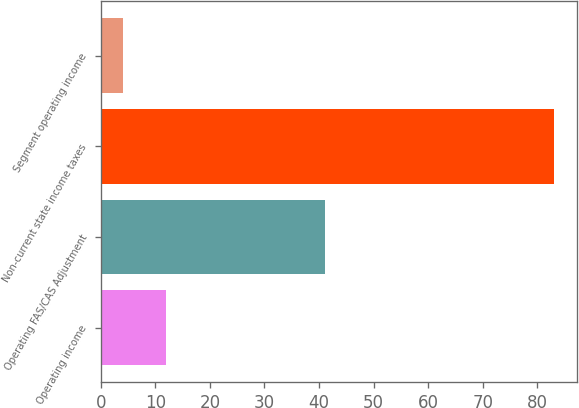Convert chart to OTSL. <chart><loc_0><loc_0><loc_500><loc_500><bar_chart><fcel>Operating income<fcel>Operating FAS/CAS Adjustment<fcel>Non-current state income taxes<fcel>Segment operating income<nl><fcel>11.9<fcel>41<fcel>83<fcel>4<nl></chart> 